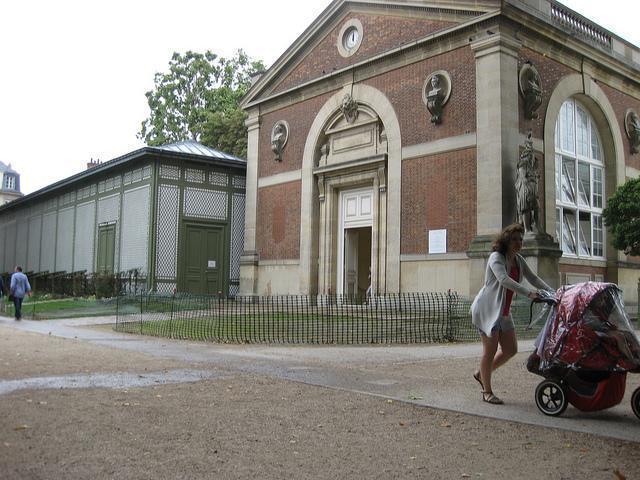What is the woman pushing?
Indicate the correct response by choosing from the four available options to answer the question.
Options: Sled, stroller, cart, wagon. Stroller. 